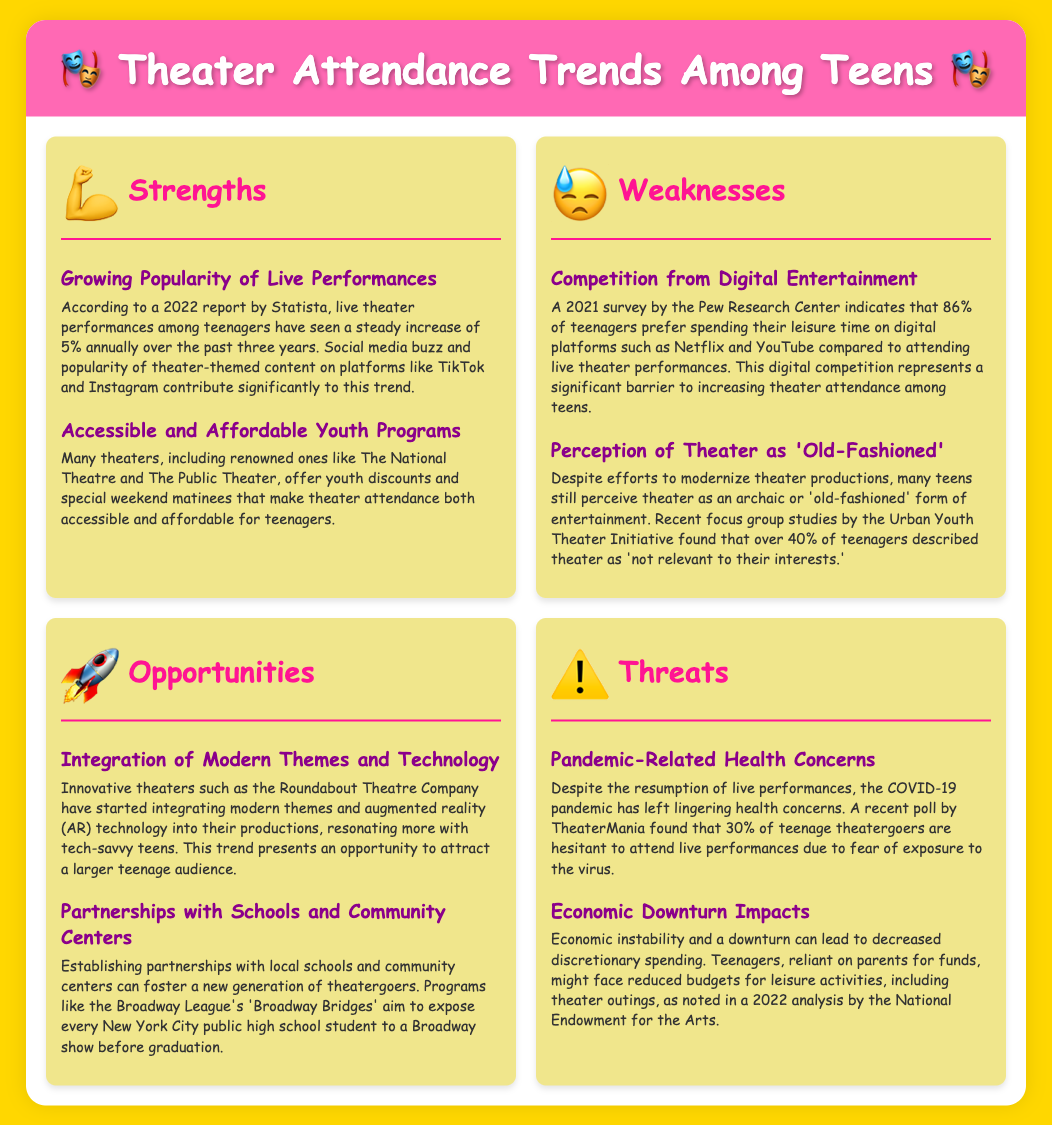What is the annual increase rate of live theater performances among teenagers? The document states that live theater performances among teenagers have seen a steady increase of 5% annually over the past three years.
Answer: 5% What percentage of teenagers prefer digital platforms for leisure time? According to a 2021 survey by the Pew Research Center, 86% of teenagers prefer spending their leisure time on digital platforms.
Answer: 86% What is one way theaters are making attendance affordable for teens? The document mentions that many theaters offer youth discounts and special weekend matinees to make theater attendance affordable.
Answer: Youth discounts What is a modern technology being integrated into theater productions? The Roundabout Theatre Company is integrating augmented reality technology into their productions.
Answer: Augmented reality What percentage of teenage theatergoers are hesitant to attend live performances due to health concerns? A poll by TheaterMania found that 30% of teenage theatergoers hesitate to attend live performances.
Answer: 30% What initiative aims to expose every New York City public high school student to a Broadway show? The Broadway League's program 'Broadway Bridges' aims to expose students to a Broadway show before graduation.
Answer: Broadway Bridges How many teenagers described theater as 'not relevant to their interests'? The Urban Youth Theater Initiative found that over 40% of teenagers viewed theater as 'not relevant to their interests.'
Answer: 40% What is the main competition for theater attendance among teens? The document states that competition from digital entertainment, such as Netflix and YouTube, is significant for theater attendance.
Answer: Digital entertainment What was identified as a weakness in the perception of theater? The perception of theater as an 'old-fashioned' form of entertainment was mentioned as a weakness.
Answer: Old-fashioned 